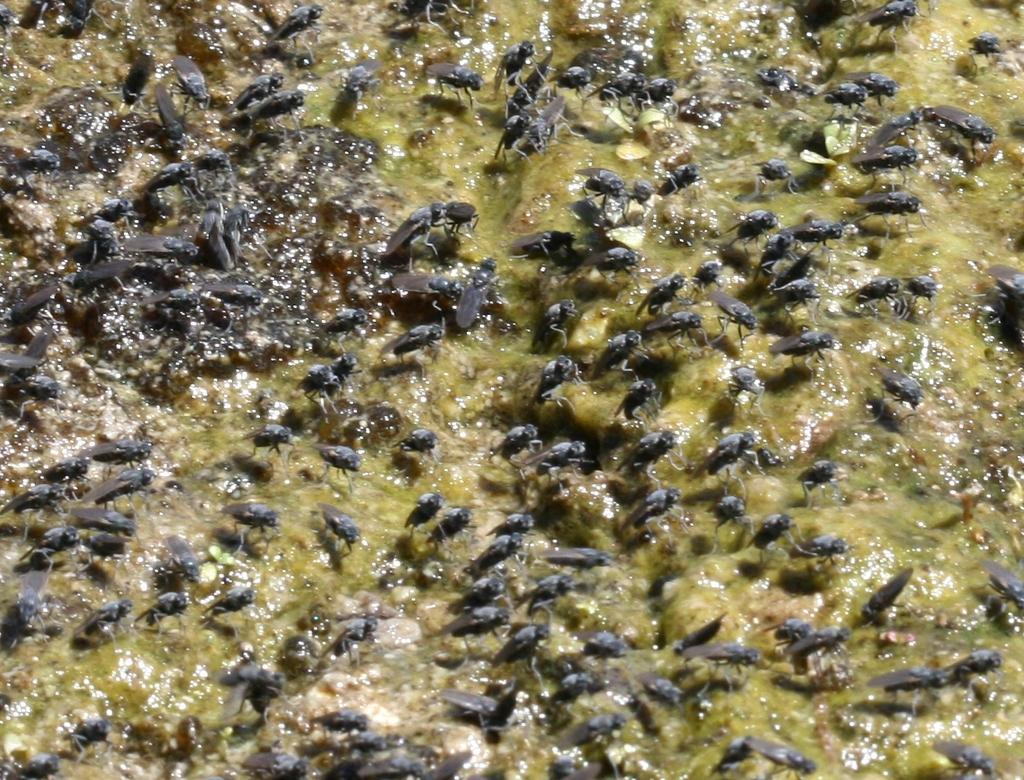What type of creatures are present in the image? There are insects in the image. Where are the insects located? The insects are on a surface. What type of pencil can be seen in the image? There is no pencil present in the image. How many glasses are visible in the image? There are no glasses present in the image. 